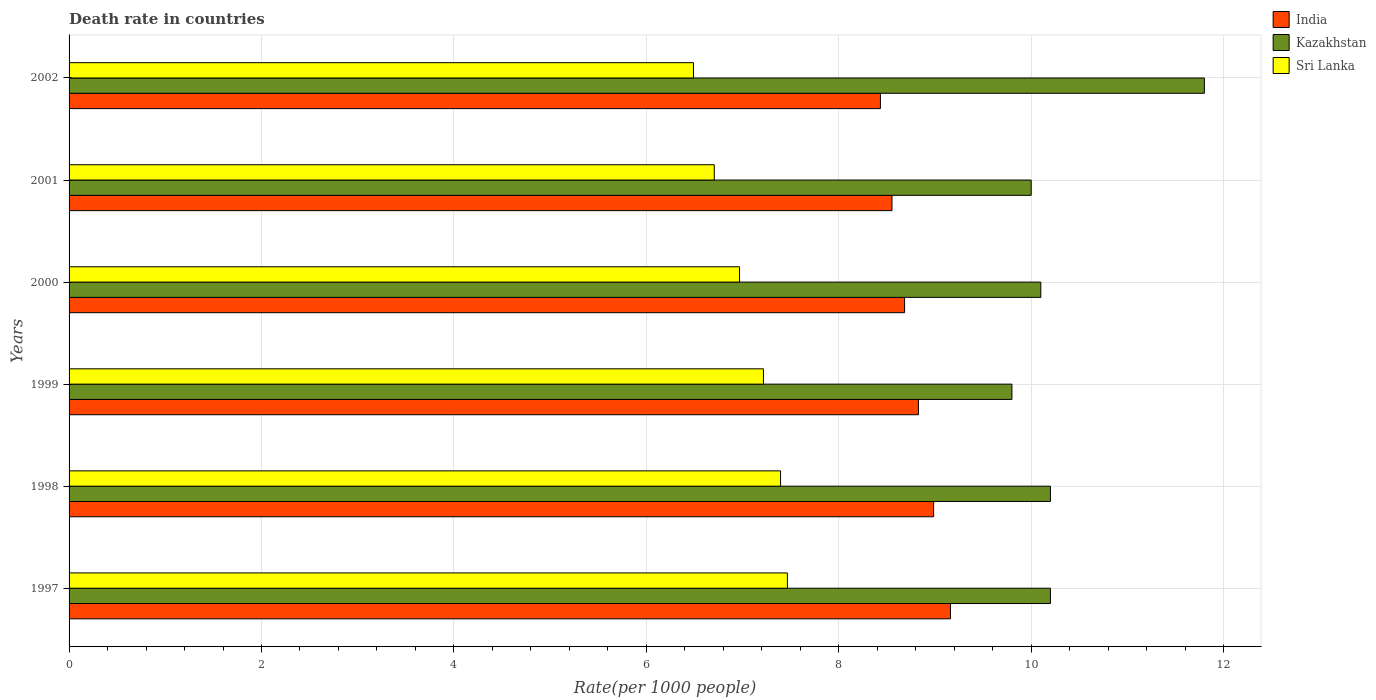How many different coloured bars are there?
Provide a short and direct response. 3. In how many cases, is the number of bars for a given year not equal to the number of legend labels?
Give a very brief answer. 0. What is the death rate in India in 1997?
Your answer should be very brief. 9.16. Across all years, what is the maximum death rate in India?
Make the answer very short. 9.16. Across all years, what is the minimum death rate in India?
Keep it short and to the point. 8.43. What is the total death rate in Kazakhstan in the graph?
Offer a terse response. 62.1. What is the difference between the death rate in India in 2000 and that in 2002?
Ensure brevity in your answer.  0.25. What is the difference between the death rate in Sri Lanka in 2001 and the death rate in Kazakhstan in 1999?
Offer a very short reply. -3.09. What is the average death rate in Kazakhstan per year?
Ensure brevity in your answer.  10.35. In the year 2000, what is the difference between the death rate in India and death rate in Sri Lanka?
Your answer should be very brief. 1.71. In how many years, is the death rate in India greater than 8.8 ?
Your answer should be compact. 3. What is the ratio of the death rate in India in 1998 to that in 2002?
Provide a short and direct response. 1.07. Is the death rate in Sri Lanka in 1997 less than that in 2000?
Give a very brief answer. No. What is the difference between the highest and the second highest death rate in Sri Lanka?
Provide a succinct answer. 0.07. In how many years, is the death rate in Sri Lanka greater than the average death rate in Sri Lanka taken over all years?
Keep it short and to the point. 3. What does the 1st bar from the bottom in 2000 represents?
Offer a very short reply. India. Are all the bars in the graph horizontal?
Offer a terse response. Yes. What is the difference between two consecutive major ticks on the X-axis?
Your answer should be compact. 2. Does the graph contain any zero values?
Offer a very short reply. No. Where does the legend appear in the graph?
Keep it short and to the point. Top right. What is the title of the graph?
Your response must be concise. Death rate in countries. Does "Congo (Republic)" appear as one of the legend labels in the graph?
Your answer should be very brief. No. What is the label or title of the X-axis?
Keep it short and to the point. Rate(per 1000 people). What is the label or title of the Y-axis?
Provide a short and direct response. Years. What is the Rate(per 1000 people) of India in 1997?
Make the answer very short. 9.16. What is the Rate(per 1000 people) in Sri Lanka in 1997?
Your response must be concise. 7.47. What is the Rate(per 1000 people) of India in 1998?
Your answer should be compact. 8.99. What is the Rate(per 1000 people) of Sri Lanka in 1998?
Make the answer very short. 7.39. What is the Rate(per 1000 people) in India in 1999?
Your answer should be compact. 8.83. What is the Rate(per 1000 people) in Sri Lanka in 1999?
Make the answer very short. 7.22. What is the Rate(per 1000 people) in India in 2000?
Your answer should be very brief. 8.68. What is the Rate(per 1000 people) in Kazakhstan in 2000?
Offer a terse response. 10.1. What is the Rate(per 1000 people) in Sri Lanka in 2000?
Provide a succinct answer. 6.97. What is the Rate(per 1000 people) of India in 2001?
Keep it short and to the point. 8.55. What is the Rate(per 1000 people) in Sri Lanka in 2001?
Make the answer very short. 6.71. What is the Rate(per 1000 people) in India in 2002?
Make the answer very short. 8.43. What is the Rate(per 1000 people) of Kazakhstan in 2002?
Keep it short and to the point. 11.8. What is the Rate(per 1000 people) of Sri Lanka in 2002?
Provide a short and direct response. 6.49. Across all years, what is the maximum Rate(per 1000 people) in India?
Offer a terse response. 9.16. Across all years, what is the maximum Rate(per 1000 people) of Sri Lanka?
Your answer should be very brief. 7.47. Across all years, what is the minimum Rate(per 1000 people) in India?
Ensure brevity in your answer.  8.43. Across all years, what is the minimum Rate(per 1000 people) in Sri Lanka?
Your response must be concise. 6.49. What is the total Rate(per 1000 people) in India in the graph?
Provide a succinct answer. 52.65. What is the total Rate(per 1000 people) in Kazakhstan in the graph?
Provide a short and direct response. 62.1. What is the total Rate(per 1000 people) of Sri Lanka in the graph?
Provide a succinct answer. 42.24. What is the difference between the Rate(per 1000 people) in India in 1997 and that in 1998?
Provide a succinct answer. 0.17. What is the difference between the Rate(per 1000 people) in Sri Lanka in 1997 and that in 1998?
Ensure brevity in your answer.  0.07. What is the difference between the Rate(per 1000 people) of India in 1997 and that in 1999?
Your response must be concise. 0.33. What is the difference between the Rate(per 1000 people) in Sri Lanka in 1997 and that in 1999?
Make the answer very short. 0.25. What is the difference between the Rate(per 1000 people) of India in 1997 and that in 2000?
Offer a terse response. 0.48. What is the difference between the Rate(per 1000 people) in Sri Lanka in 1997 and that in 2000?
Your answer should be compact. 0.5. What is the difference between the Rate(per 1000 people) in India in 1997 and that in 2001?
Keep it short and to the point. 0.61. What is the difference between the Rate(per 1000 people) of Kazakhstan in 1997 and that in 2001?
Keep it short and to the point. 0.2. What is the difference between the Rate(per 1000 people) in Sri Lanka in 1997 and that in 2001?
Offer a very short reply. 0.76. What is the difference between the Rate(per 1000 people) in India in 1997 and that in 2002?
Provide a succinct answer. 0.73. What is the difference between the Rate(per 1000 people) of India in 1998 and that in 1999?
Your answer should be very brief. 0.16. What is the difference between the Rate(per 1000 people) of Sri Lanka in 1998 and that in 1999?
Ensure brevity in your answer.  0.18. What is the difference between the Rate(per 1000 people) in India in 1998 and that in 2000?
Your answer should be very brief. 0.3. What is the difference between the Rate(per 1000 people) in Sri Lanka in 1998 and that in 2000?
Give a very brief answer. 0.43. What is the difference between the Rate(per 1000 people) in India in 1998 and that in 2001?
Provide a succinct answer. 0.43. What is the difference between the Rate(per 1000 people) of Sri Lanka in 1998 and that in 2001?
Offer a terse response. 0.69. What is the difference between the Rate(per 1000 people) of India in 1998 and that in 2002?
Offer a terse response. 0.55. What is the difference between the Rate(per 1000 people) in Kazakhstan in 1998 and that in 2002?
Ensure brevity in your answer.  -1.6. What is the difference between the Rate(per 1000 people) of Sri Lanka in 1998 and that in 2002?
Provide a succinct answer. 0.91. What is the difference between the Rate(per 1000 people) in India in 1999 and that in 2000?
Make the answer very short. 0.14. What is the difference between the Rate(per 1000 people) of Kazakhstan in 1999 and that in 2000?
Your response must be concise. -0.3. What is the difference between the Rate(per 1000 people) of Sri Lanka in 1999 and that in 2000?
Make the answer very short. 0.25. What is the difference between the Rate(per 1000 people) of India in 1999 and that in 2001?
Make the answer very short. 0.28. What is the difference between the Rate(per 1000 people) of Kazakhstan in 1999 and that in 2001?
Offer a terse response. -0.2. What is the difference between the Rate(per 1000 people) of Sri Lanka in 1999 and that in 2001?
Give a very brief answer. 0.51. What is the difference between the Rate(per 1000 people) of India in 1999 and that in 2002?
Ensure brevity in your answer.  0.4. What is the difference between the Rate(per 1000 people) of Sri Lanka in 1999 and that in 2002?
Provide a short and direct response. 0.73. What is the difference between the Rate(per 1000 people) in India in 2000 and that in 2001?
Offer a very short reply. 0.13. What is the difference between the Rate(per 1000 people) in Sri Lanka in 2000 and that in 2001?
Provide a short and direct response. 0.26. What is the difference between the Rate(per 1000 people) in India in 2000 and that in 2002?
Your answer should be very brief. 0.25. What is the difference between the Rate(per 1000 people) in Sri Lanka in 2000 and that in 2002?
Offer a terse response. 0.48. What is the difference between the Rate(per 1000 people) of India in 2001 and that in 2002?
Offer a very short reply. 0.12. What is the difference between the Rate(per 1000 people) in Kazakhstan in 2001 and that in 2002?
Offer a terse response. -1.8. What is the difference between the Rate(per 1000 people) in Sri Lanka in 2001 and that in 2002?
Offer a terse response. 0.22. What is the difference between the Rate(per 1000 people) of India in 1997 and the Rate(per 1000 people) of Kazakhstan in 1998?
Provide a short and direct response. -1.04. What is the difference between the Rate(per 1000 people) in India in 1997 and the Rate(per 1000 people) in Sri Lanka in 1998?
Ensure brevity in your answer.  1.77. What is the difference between the Rate(per 1000 people) of Kazakhstan in 1997 and the Rate(per 1000 people) of Sri Lanka in 1998?
Offer a very short reply. 2.81. What is the difference between the Rate(per 1000 people) in India in 1997 and the Rate(per 1000 people) in Kazakhstan in 1999?
Offer a terse response. -0.64. What is the difference between the Rate(per 1000 people) in India in 1997 and the Rate(per 1000 people) in Sri Lanka in 1999?
Offer a terse response. 1.94. What is the difference between the Rate(per 1000 people) of Kazakhstan in 1997 and the Rate(per 1000 people) of Sri Lanka in 1999?
Provide a succinct answer. 2.98. What is the difference between the Rate(per 1000 people) in India in 1997 and the Rate(per 1000 people) in Kazakhstan in 2000?
Make the answer very short. -0.94. What is the difference between the Rate(per 1000 people) in India in 1997 and the Rate(per 1000 people) in Sri Lanka in 2000?
Your answer should be very brief. 2.19. What is the difference between the Rate(per 1000 people) of Kazakhstan in 1997 and the Rate(per 1000 people) of Sri Lanka in 2000?
Your answer should be very brief. 3.23. What is the difference between the Rate(per 1000 people) of India in 1997 and the Rate(per 1000 people) of Kazakhstan in 2001?
Your answer should be compact. -0.84. What is the difference between the Rate(per 1000 people) in India in 1997 and the Rate(per 1000 people) in Sri Lanka in 2001?
Ensure brevity in your answer.  2.46. What is the difference between the Rate(per 1000 people) of Kazakhstan in 1997 and the Rate(per 1000 people) of Sri Lanka in 2001?
Your response must be concise. 3.49. What is the difference between the Rate(per 1000 people) in India in 1997 and the Rate(per 1000 people) in Kazakhstan in 2002?
Keep it short and to the point. -2.64. What is the difference between the Rate(per 1000 people) in India in 1997 and the Rate(per 1000 people) in Sri Lanka in 2002?
Make the answer very short. 2.67. What is the difference between the Rate(per 1000 people) in Kazakhstan in 1997 and the Rate(per 1000 people) in Sri Lanka in 2002?
Provide a succinct answer. 3.71. What is the difference between the Rate(per 1000 people) of India in 1998 and the Rate(per 1000 people) of Kazakhstan in 1999?
Give a very brief answer. -0.81. What is the difference between the Rate(per 1000 people) of India in 1998 and the Rate(per 1000 people) of Sri Lanka in 1999?
Your response must be concise. 1.77. What is the difference between the Rate(per 1000 people) in Kazakhstan in 1998 and the Rate(per 1000 people) in Sri Lanka in 1999?
Your response must be concise. 2.98. What is the difference between the Rate(per 1000 people) of India in 1998 and the Rate(per 1000 people) of Kazakhstan in 2000?
Offer a terse response. -1.11. What is the difference between the Rate(per 1000 people) of India in 1998 and the Rate(per 1000 people) of Sri Lanka in 2000?
Your answer should be very brief. 2.02. What is the difference between the Rate(per 1000 people) of Kazakhstan in 1998 and the Rate(per 1000 people) of Sri Lanka in 2000?
Your answer should be very brief. 3.23. What is the difference between the Rate(per 1000 people) in India in 1998 and the Rate(per 1000 people) in Kazakhstan in 2001?
Your answer should be compact. -1.01. What is the difference between the Rate(per 1000 people) of India in 1998 and the Rate(per 1000 people) of Sri Lanka in 2001?
Provide a succinct answer. 2.28. What is the difference between the Rate(per 1000 people) in Kazakhstan in 1998 and the Rate(per 1000 people) in Sri Lanka in 2001?
Ensure brevity in your answer.  3.49. What is the difference between the Rate(per 1000 people) in India in 1998 and the Rate(per 1000 people) in Kazakhstan in 2002?
Offer a terse response. -2.81. What is the difference between the Rate(per 1000 people) of India in 1998 and the Rate(per 1000 people) of Sri Lanka in 2002?
Give a very brief answer. 2.5. What is the difference between the Rate(per 1000 people) of Kazakhstan in 1998 and the Rate(per 1000 people) of Sri Lanka in 2002?
Offer a very short reply. 3.71. What is the difference between the Rate(per 1000 people) in India in 1999 and the Rate(per 1000 people) in Kazakhstan in 2000?
Your response must be concise. -1.27. What is the difference between the Rate(per 1000 people) of India in 1999 and the Rate(per 1000 people) of Sri Lanka in 2000?
Provide a succinct answer. 1.86. What is the difference between the Rate(per 1000 people) in Kazakhstan in 1999 and the Rate(per 1000 people) in Sri Lanka in 2000?
Keep it short and to the point. 2.83. What is the difference between the Rate(per 1000 people) of India in 1999 and the Rate(per 1000 people) of Kazakhstan in 2001?
Give a very brief answer. -1.17. What is the difference between the Rate(per 1000 people) in India in 1999 and the Rate(per 1000 people) in Sri Lanka in 2001?
Provide a succinct answer. 2.12. What is the difference between the Rate(per 1000 people) of Kazakhstan in 1999 and the Rate(per 1000 people) of Sri Lanka in 2001?
Give a very brief answer. 3.09. What is the difference between the Rate(per 1000 people) in India in 1999 and the Rate(per 1000 people) in Kazakhstan in 2002?
Offer a terse response. -2.97. What is the difference between the Rate(per 1000 people) in India in 1999 and the Rate(per 1000 people) in Sri Lanka in 2002?
Your answer should be very brief. 2.34. What is the difference between the Rate(per 1000 people) of Kazakhstan in 1999 and the Rate(per 1000 people) of Sri Lanka in 2002?
Your response must be concise. 3.31. What is the difference between the Rate(per 1000 people) of India in 2000 and the Rate(per 1000 people) of Kazakhstan in 2001?
Keep it short and to the point. -1.32. What is the difference between the Rate(per 1000 people) of India in 2000 and the Rate(per 1000 people) of Sri Lanka in 2001?
Provide a short and direct response. 1.98. What is the difference between the Rate(per 1000 people) of Kazakhstan in 2000 and the Rate(per 1000 people) of Sri Lanka in 2001?
Keep it short and to the point. 3.39. What is the difference between the Rate(per 1000 people) of India in 2000 and the Rate(per 1000 people) of Kazakhstan in 2002?
Offer a very short reply. -3.12. What is the difference between the Rate(per 1000 people) of India in 2000 and the Rate(per 1000 people) of Sri Lanka in 2002?
Offer a very short reply. 2.19. What is the difference between the Rate(per 1000 people) in Kazakhstan in 2000 and the Rate(per 1000 people) in Sri Lanka in 2002?
Your answer should be very brief. 3.61. What is the difference between the Rate(per 1000 people) in India in 2001 and the Rate(per 1000 people) in Kazakhstan in 2002?
Keep it short and to the point. -3.25. What is the difference between the Rate(per 1000 people) in India in 2001 and the Rate(per 1000 people) in Sri Lanka in 2002?
Your answer should be compact. 2.06. What is the difference between the Rate(per 1000 people) in Kazakhstan in 2001 and the Rate(per 1000 people) in Sri Lanka in 2002?
Your answer should be very brief. 3.51. What is the average Rate(per 1000 people) in India per year?
Provide a succinct answer. 8.77. What is the average Rate(per 1000 people) in Kazakhstan per year?
Ensure brevity in your answer.  10.35. What is the average Rate(per 1000 people) in Sri Lanka per year?
Give a very brief answer. 7.04. In the year 1997, what is the difference between the Rate(per 1000 people) in India and Rate(per 1000 people) in Kazakhstan?
Offer a terse response. -1.04. In the year 1997, what is the difference between the Rate(per 1000 people) in India and Rate(per 1000 people) in Sri Lanka?
Provide a short and direct response. 1.7. In the year 1997, what is the difference between the Rate(per 1000 people) of Kazakhstan and Rate(per 1000 people) of Sri Lanka?
Your response must be concise. 2.73. In the year 1998, what is the difference between the Rate(per 1000 people) in India and Rate(per 1000 people) in Kazakhstan?
Your answer should be compact. -1.21. In the year 1998, what is the difference between the Rate(per 1000 people) in India and Rate(per 1000 people) in Sri Lanka?
Provide a succinct answer. 1.59. In the year 1998, what is the difference between the Rate(per 1000 people) in Kazakhstan and Rate(per 1000 people) in Sri Lanka?
Make the answer very short. 2.81. In the year 1999, what is the difference between the Rate(per 1000 people) in India and Rate(per 1000 people) in Kazakhstan?
Provide a short and direct response. -0.97. In the year 1999, what is the difference between the Rate(per 1000 people) in India and Rate(per 1000 people) in Sri Lanka?
Ensure brevity in your answer.  1.61. In the year 1999, what is the difference between the Rate(per 1000 people) of Kazakhstan and Rate(per 1000 people) of Sri Lanka?
Keep it short and to the point. 2.58. In the year 2000, what is the difference between the Rate(per 1000 people) of India and Rate(per 1000 people) of Kazakhstan?
Your response must be concise. -1.42. In the year 2000, what is the difference between the Rate(per 1000 people) of India and Rate(per 1000 people) of Sri Lanka?
Make the answer very short. 1.72. In the year 2000, what is the difference between the Rate(per 1000 people) of Kazakhstan and Rate(per 1000 people) of Sri Lanka?
Give a very brief answer. 3.13. In the year 2001, what is the difference between the Rate(per 1000 people) in India and Rate(per 1000 people) in Kazakhstan?
Your response must be concise. -1.45. In the year 2001, what is the difference between the Rate(per 1000 people) in India and Rate(per 1000 people) in Sri Lanka?
Offer a terse response. 1.85. In the year 2001, what is the difference between the Rate(per 1000 people) in Kazakhstan and Rate(per 1000 people) in Sri Lanka?
Offer a terse response. 3.29. In the year 2002, what is the difference between the Rate(per 1000 people) of India and Rate(per 1000 people) of Kazakhstan?
Your answer should be compact. -3.37. In the year 2002, what is the difference between the Rate(per 1000 people) in India and Rate(per 1000 people) in Sri Lanka?
Your response must be concise. 1.94. In the year 2002, what is the difference between the Rate(per 1000 people) of Kazakhstan and Rate(per 1000 people) of Sri Lanka?
Provide a succinct answer. 5.31. What is the ratio of the Rate(per 1000 people) in India in 1997 to that in 1998?
Make the answer very short. 1.02. What is the ratio of the Rate(per 1000 people) in Kazakhstan in 1997 to that in 1998?
Offer a terse response. 1. What is the ratio of the Rate(per 1000 people) in Sri Lanka in 1997 to that in 1998?
Your answer should be very brief. 1.01. What is the ratio of the Rate(per 1000 people) in India in 1997 to that in 1999?
Give a very brief answer. 1.04. What is the ratio of the Rate(per 1000 people) in Kazakhstan in 1997 to that in 1999?
Your response must be concise. 1.04. What is the ratio of the Rate(per 1000 people) of Sri Lanka in 1997 to that in 1999?
Give a very brief answer. 1.03. What is the ratio of the Rate(per 1000 people) in India in 1997 to that in 2000?
Provide a succinct answer. 1.05. What is the ratio of the Rate(per 1000 people) of Kazakhstan in 1997 to that in 2000?
Your response must be concise. 1.01. What is the ratio of the Rate(per 1000 people) in Sri Lanka in 1997 to that in 2000?
Make the answer very short. 1.07. What is the ratio of the Rate(per 1000 people) of India in 1997 to that in 2001?
Give a very brief answer. 1.07. What is the ratio of the Rate(per 1000 people) of Kazakhstan in 1997 to that in 2001?
Provide a succinct answer. 1.02. What is the ratio of the Rate(per 1000 people) in Sri Lanka in 1997 to that in 2001?
Offer a very short reply. 1.11. What is the ratio of the Rate(per 1000 people) in India in 1997 to that in 2002?
Offer a terse response. 1.09. What is the ratio of the Rate(per 1000 people) in Kazakhstan in 1997 to that in 2002?
Keep it short and to the point. 0.86. What is the ratio of the Rate(per 1000 people) of Sri Lanka in 1997 to that in 2002?
Your answer should be compact. 1.15. What is the ratio of the Rate(per 1000 people) in India in 1998 to that in 1999?
Make the answer very short. 1.02. What is the ratio of the Rate(per 1000 people) in Kazakhstan in 1998 to that in 1999?
Provide a succinct answer. 1.04. What is the ratio of the Rate(per 1000 people) of Sri Lanka in 1998 to that in 1999?
Your answer should be very brief. 1.02. What is the ratio of the Rate(per 1000 people) of India in 1998 to that in 2000?
Provide a short and direct response. 1.03. What is the ratio of the Rate(per 1000 people) in Kazakhstan in 1998 to that in 2000?
Offer a terse response. 1.01. What is the ratio of the Rate(per 1000 people) of Sri Lanka in 1998 to that in 2000?
Your answer should be compact. 1.06. What is the ratio of the Rate(per 1000 people) of India in 1998 to that in 2001?
Make the answer very short. 1.05. What is the ratio of the Rate(per 1000 people) of Sri Lanka in 1998 to that in 2001?
Offer a very short reply. 1.1. What is the ratio of the Rate(per 1000 people) in India in 1998 to that in 2002?
Offer a terse response. 1.07. What is the ratio of the Rate(per 1000 people) of Kazakhstan in 1998 to that in 2002?
Make the answer very short. 0.86. What is the ratio of the Rate(per 1000 people) of Sri Lanka in 1998 to that in 2002?
Offer a very short reply. 1.14. What is the ratio of the Rate(per 1000 people) in India in 1999 to that in 2000?
Your answer should be compact. 1.02. What is the ratio of the Rate(per 1000 people) of Kazakhstan in 1999 to that in 2000?
Make the answer very short. 0.97. What is the ratio of the Rate(per 1000 people) of Sri Lanka in 1999 to that in 2000?
Make the answer very short. 1.04. What is the ratio of the Rate(per 1000 people) of India in 1999 to that in 2001?
Your answer should be compact. 1.03. What is the ratio of the Rate(per 1000 people) in Sri Lanka in 1999 to that in 2001?
Provide a short and direct response. 1.08. What is the ratio of the Rate(per 1000 people) in India in 1999 to that in 2002?
Your answer should be compact. 1.05. What is the ratio of the Rate(per 1000 people) of Kazakhstan in 1999 to that in 2002?
Your answer should be very brief. 0.83. What is the ratio of the Rate(per 1000 people) in Sri Lanka in 1999 to that in 2002?
Keep it short and to the point. 1.11. What is the ratio of the Rate(per 1000 people) in India in 2000 to that in 2001?
Your answer should be compact. 1.02. What is the ratio of the Rate(per 1000 people) of Sri Lanka in 2000 to that in 2001?
Offer a very short reply. 1.04. What is the ratio of the Rate(per 1000 people) in India in 2000 to that in 2002?
Offer a very short reply. 1.03. What is the ratio of the Rate(per 1000 people) in Kazakhstan in 2000 to that in 2002?
Provide a short and direct response. 0.86. What is the ratio of the Rate(per 1000 people) of Sri Lanka in 2000 to that in 2002?
Offer a very short reply. 1.07. What is the ratio of the Rate(per 1000 people) in India in 2001 to that in 2002?
Keep it short and to the point. 1.01. What is the ratio of the Rate(per 1000 people) in Kazakhstan in 2001 to that in 2002?
Keep it short and to the point. 0.85. What is the difference between the highest and the second highest Rate(per 1000 people) in India?
Give a very brief answer. 0.17. What is the difference between the highest and the second highest Rate(per 1000 people) of Kazakhstan?
Keep it short and to the point. 1.6. What is the difference between the highest and the second highest Rate(per 1000 people) of Sri Lanka?
Provide a succinct answer. 0.07. What is the difference between the highest and the lowest Rate(per 1000 people) in India?
Provide a succinct answer. 0.73. 